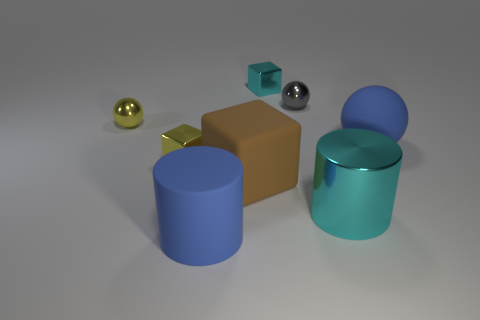Add 1 tiny brown shiny cubes. How many objects exist? 9 Subtract all cylinders. How many objects are left? 6 Subtract 0 red spheres. How many objects are left? 8 Subtract all cyan metallic objects. Subtract all big metallic objects. How many objects are left? 5 Add 8 cyan metallic cylinders. How many cyan metallic cylinders are left? 9 Add 2 blue spheres. How many blue spheres exist? 3 